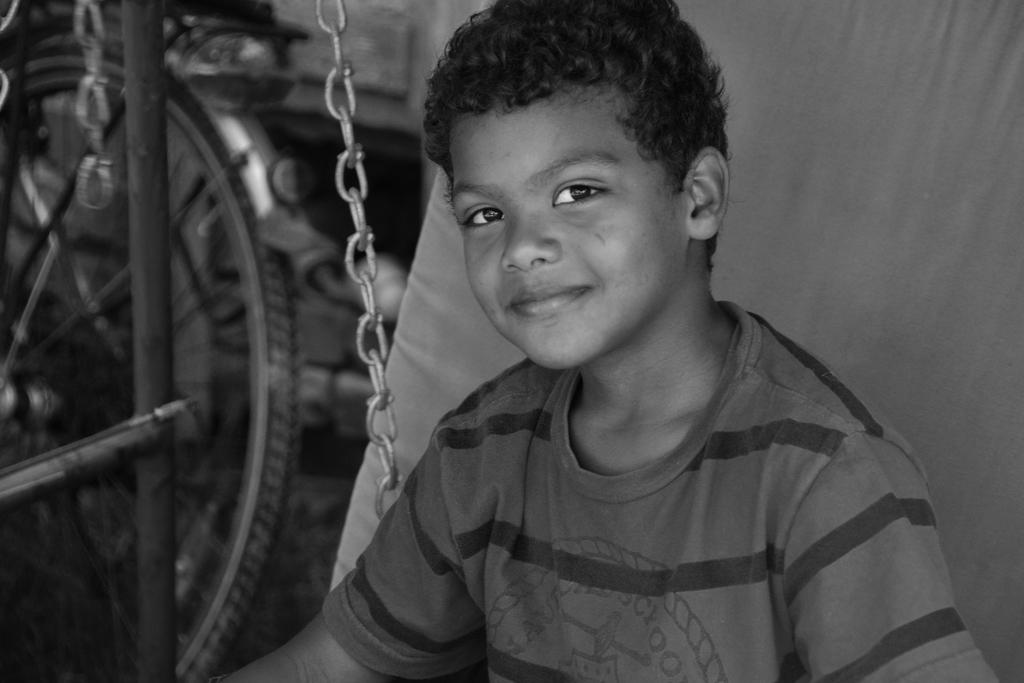Who is present in the image? There is a boy in the image. What is the boy's expression? The boy is smiling. What can be seen in the background of the image? There is a bicycle wheel and other objects visible in the background of the image. How many thumbs does the boy have on his quilt in the image? There is no quilt or mention of thumbs in the image; it only features a boy and a bicycle wheel in the background. 